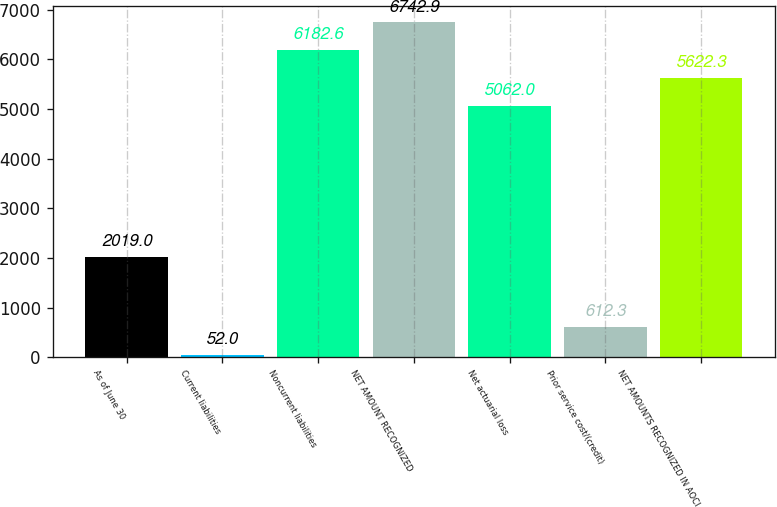Convert chart. <chart><loc_0><loc_0><loc_500><loc_500><bar_chart><fcel>As of June 30<fcel>Current liabilities<fcel>Noncurrent liabilities<fcel>NET AMOUNT RECOGNIZED<fcel>Net actuarial loss<fcel>Prior service cost/(credit)<fcel>NET AMOUNTS RECOGNIZED IN AOCI<nl><fcel>2019<fcel>52<fcel>6182.6<fcel>6742.9<fcel>5062<fcel>612.3<fcel>5622.3<nl></chart> 